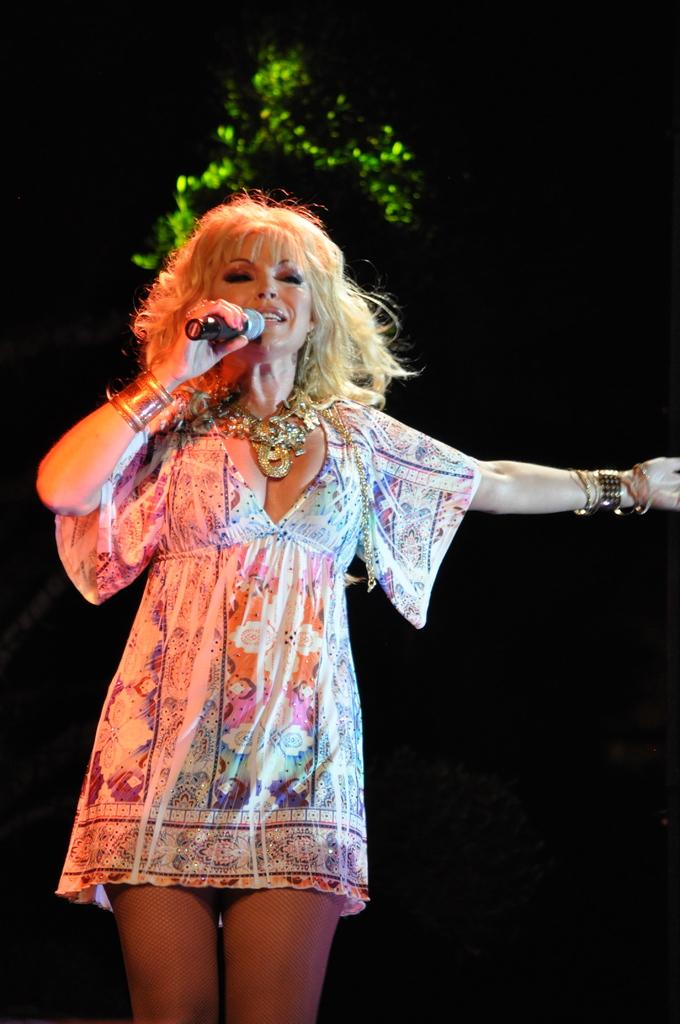What is the main subject of the image? The main subject of the image is a woman. What is the woman holding in the image? The woman is holding a microphone. What can be seen in the background of the image? There is a green color tree in the background of the image. What grade is the woman teaching in the image? There is no indication in the image that the woman is teaching, nor is there any information about a grade. 